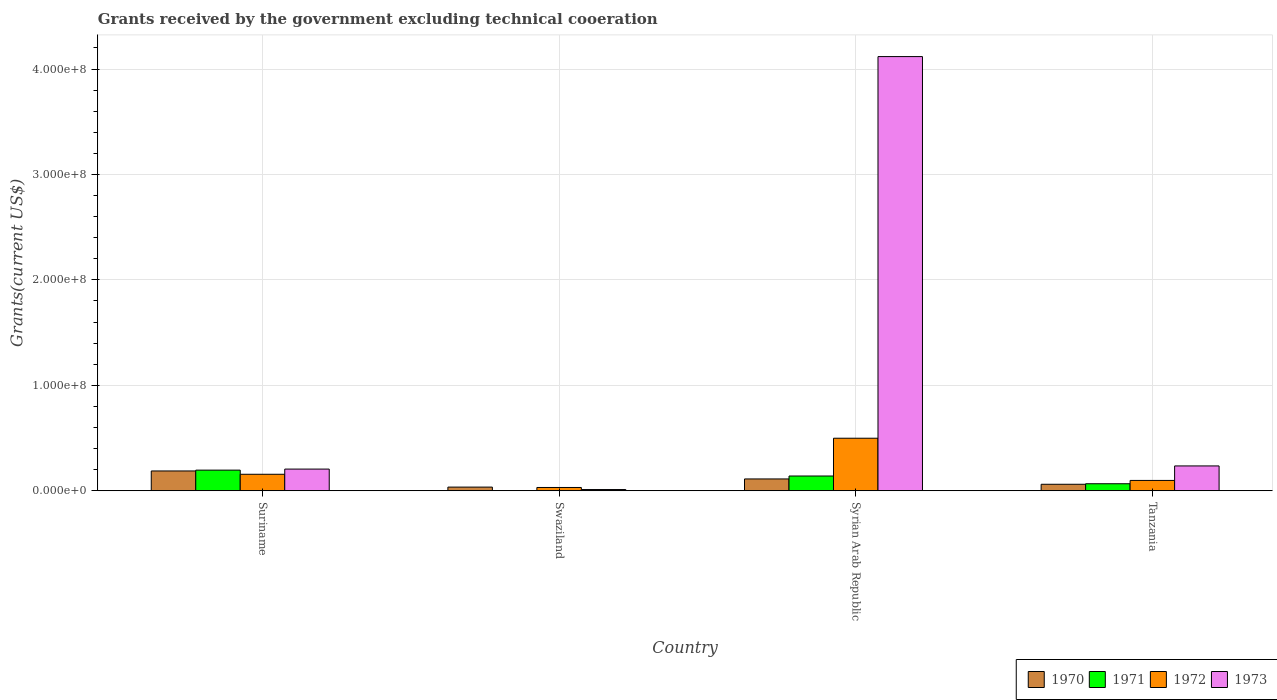How many different coloured bars are there?
Make the answer very short. 4. How many groups of bars are there?
Your response must be concise. 4. Are the number of bars on each tick of the X-axis equal?
Keep it short and to the point. No. How many bars are there on the 3rd tick from the left?
Give a very brief answer. 4. How many bars are there on the 2nd tick from the right?
Make the answer very short. 4. What is the label of the 3rd group of bars from the left?
Keep it short and to the point. Syrian Arab Republic. In how many cases, is the number of bars for a given country not equal to the number of legend labels?
Provide a short and direct response. 1. What is the total grants received by the government in 1971 in Suriname?
Your answer should be compact. 1.96e+07. Across all countries, what is the maximum total grants received by the government in 1971?
Ensure brevity in your answer.  1.96e+07. Across all countries, what is the minimum total grants received by the government in 1971?
Keep it short and to the point. 0. In which country was the total grants received by the government in 1972 maximum?
Provide a succinct answer. Syrian Arab Republic. What is the total total grants received by the government in 1970 in the graph?
Keep it short and to the point. 3.97e+07. What is the difference between the total grants received by the government in 1972 in Swaziland and that in Syrian Arab Republic?
Provide a short and direct response. -4.67e+07. What is the difference between the total grants received by the government in 1972 in Swaziland and the total grants received by the government in 1971 in Tanzania?
Provide a short and direct response. -3.54e+06. What is the average total grants received by the government in 1972 per country?
Offer a terse response. 1.96e+07. What is the difference between the total grants received by the government of/in 1971 and total grants received by the government of/in 1970 in Syrian Arab Republic?
Your response must be concise. 2.78e+06. What is the ratio of the total grants received by the government in 1973 in Suriname to that in Syrian Arab Republic?
Your answer should be compact. 0.05. Is the total grants received by the government in 1970 in Suriname less than that in Syrian Arab Republic?
Your answer should be very brief. No. What is the difference between the highest and the second highest total grants received by the government in 1971?
Give a very brief answer. 5.58e+06. What is the difference between the highest and the lowest total grants received by the government in 1973?
Keep it short and to the point. 4.11e+08. In how many countries, is the total grants received by the government in 1973 greater than the average total grants received by the government in 1973 taken over all countries?
Your response must be concise. 1. Is it the case that in every country, the sum of the total grants received by the government in 1971 and total grants received by the government in 1972 is greater than the sum of total grants received by the government in 1970 and total grants received by the government in 1973?
Keep it short and to the point. No. Is it the case that in every country, the sum of the total grants received by the government in 1970 and total grants received by the government in 1971 is greater than the total grants received by the government in 1972?
Your response must be concise. No. How many bars are there?
Keep it short and to the point. 15. How many countries are there in the graph?
Keep it short and to the point. 4. Does the graph contain grids?
Your answer should be compact. Yes. Where does the legend appear in the graph?
Your response must be concise. Bottom right. How many legend labels are there?
Provide a succinct answer. 4. What is the title of the graph?
Ensure brevity in your answer.  Grants received by the government excluding technical cooeration. What is the label or title of the X-axis?
Offer a very short reply. Country. What is the label or title of the Y-axis?
Keep it short and to the point. Grants(current US$). What is the Grants(current US$) in 1970 in Suriname?
Your answer should be compact. 1.88e+07. What is the Grants(current US$) in 1971 in Suriname?
Keep it short and to the point. 1.96e+07. What is the Grants(current US$) in 1972 in Suriname?
Give a very brief answer. 1.57e+07. What is the Grants(current US$) of 1973 in Suriname?
Keep it short and to the point. 2.06e+07. What is the Grants(current US$) of 1970 in Swaziland?
Your answer should be compact. 3.49e+06. What is the Grants(current US$) in 1971 in Swaziland?
Provide a succinct answer. 0. What is the Grants(current US$) in 1972 in Swaziland?
Your response must be concise. 3.14e+06. What is the Grants(current US$) of 1973 in Swaziland?
Offer a very short reply. 1.18e+06. What is the Grants(current US$) of 1970 in Syrian Arab Republic?
Provide a succinct answer. 1.12e+07. What is the Grants(current US$) in 1971 in Syrian Arab Republic?
Offer a terse response. 1.40e+07. What is the Grants(current US$) of 1972 in Syrian Arab Republic?
Your answer should be very brief. 4.98e+07. What is the Grants(current US$) in 1973 in Syrian Arab Republic?
Give a very brief answer. 4.12e+08. What is the Grants(current US$) in 1970 in Tanzania?
Offer a very short reply. 6.17e+06. What is the Grants(current US$) in 1971 in Tanzania?
Provide a succinct answer. 6.68e+06. What is the Grants(current US$) of 1972 in Tanzania?
Offer a very short reply. 9.82e+06. What is the Grants(current US$) of 1973 in Tanzania?
Ensure brevity in your answer.  2.36e+07. Across all countries, what is the maximum Grants(current US$) in 1970?
Provide a short and direct response. 1.88e+07. Across all countries, what is the maximum Grants(current US$) of 1971?
Make the answer very short. 1.96e+07. Across all countries, what is the maximum Grants(current US$) of 1972?
Make the answer very short. 4.98e+07. Across all countries, what is the maximum Grants(current US$) of 1973?
Offer a terse response. 4.12e+08. Across all countries, what is the minimum Grants(current US$) in 1970?
Your response must be concise. 3.49e+06. Across all countries, what is the minimum Grants(current US$) of 1972?
Your answer should be compact. 3.14e+06. Across all countries, what is the minimum Grants(current US$) of 1973?
Provide a succinct answer. 1.18e+06. What is the total Grants(current US$) of 1970 in the graph?
Provide a short and direct response. 3.97e+07. What is the total Grants(current US$) in 1971 in the graph?
Your response must be concise. 4.03e+07. What is the total Grants(current US$) in 1972 in the graph?
Keep it short and to the point. 7.85e+07. What is the total Grants(current US$) in 1973 in the graph?
Provide a short and direct response. 4.57e+08. What is the difference between the Grants(current US$) of 1970 in Suriname and that in Swaziland?
Provide a succinct answer. 1.53e+07. What is the difference between the Grants(current US$) in 1972 in Suriname and that in Swaziland?
Your answer should be compact. 1.25e+07. What is the difference between the Grants(current US$) in 1973 in Suriname and that in Swaziland?
Provide a short and direct response. 1.94e+07. What is the difference between the Grants(current US$) of 1970 in Suriname and that in Syrian Arab Republic?
Keep it short and to the point. 7.58e+06. What is the difference between the Grants(current US$) of 1971 in Suriname and that in Syrian Arab Republic?
Give a very brief answer. 5.58e+06. What is the difference between the Grants(current US$) of 1972 in Suriname and that in Syrian Arab Republic?
Your answer should be compact. -3.42e+07. What is the difference between the Grants(current US$) in 1973 in Suriname and that in Syrian Arab Republic?
Your answer should be compact. -3.91e+08. What is the difference between the Grants(current US$) in 1970 in Suriname and that in Tanzania?
Provide a short and direct response. 1.26e+07. What is the difference between the Grants(current US$) of 1971 in Suriname and that in Tanzania?
Offer a very short reply. 1.29e+07. What is the difference between the Grants(current US$) in 1972 in Suriname and that in Tanzania?
Offer a very short reply. 5.84e+06. What is the difference between the Grants(current US$) of 1970 in Swaziland and that in Syrian Arab Republic?
Provide a succinct answer. -7.74e+06. What is the difference between the Grants(current US$) in 1972 in Swaziland and that in Syrian Arab Republic?
Give a very brief answer. -4.67e+07. What is the difference between the Grants(current US$) in 1973 in Swaziland and that in Syrian Arab Republic?
Your response must be concise. -4.11e+08. What is the difference between the Grants(current US$) of 1970 in Swaziland and that in Tanzania?
Give a very brief answer. -2.68e+06. What is the difference between the Grants(current US$) in 1972 in Swaziland and that in Tanzania?
Your answer should be very brief. -6.68e+06. What is the difference between the Grants(current US$) of 1973 in Swaziland and that in Tanzania?
Make the answer very short. -2.24e+07. What is the difference between the Grants(current US$) of 1970 in Syrian Arab Republic and that in Tanzania?
Offer a very short reply. 5.06e+06. What is the difference between the Grants(current US$) in 1971 in Syrian Arab Republic and that in Tanzania?
Provide a short and direct response. 7.33e+06. What is the difference between the Grants(current US$) in 1972 in Syrian Arab Republic and that in Tanzania?
Ensure brevity in your answer.  4.00e+07. What is the difference between the Grants(current US$) of 1973 in Syrian Arab Republic and that in Tanzania?
Give a very brief answer. 3.88e+08. What is the difference between the Grants(current US$) in 1970 in Suriname and the Grants(current US$) in 1972 in Swaziland?
Provide a short and direct response. 1.57e+07. What is the difference between the Grants(current US$) of 1970 in Suriname and the Grants(current US$) of 1973 in Swaziland?
Provide a succinct answer. 1.76e+07. What is the difference between the Grants(current US$) of 1971 in Suriname and the Grants(current US$) of 1972 in Swaziland?
Ensure brevity in your answer.  1.64e+07. What is the difference between the Grants(current US$) in 1971 in Suriname and the Grants(current US$) in 1973 in Swaziland?
Keep it short and to the point. 1.84e+07. What is the difference between the Grants(current US$) in 1972 in Suriname and the Grants(current US$) in 1973 in Swaziland?
Make the answer very short. 1.45e+07. What is the difference between the Grants(current US$) of 1970 in Suriname and the Grants(current US$) of 1971 in Syrian Arab Republic?
Provide a short and direct response. 4.80e+06. What is the difference between the Grants(current US$) in 1970 in Suriname and the Grants(current US$) in 1972 in Syrian Arab Republic?
Give a very brief answer. -3.10e+07. What is the difference between the Grants(current US$) of 1970 in Suriname and the Grants(current US$) of 1973 in Syrian Arab Republic?
Provide a succinct answer. -3.93e+08. What is the difference between the Grants(current US$) in 1971 in Suriname and the Grants(current US$) in 1972 in Syrian Arab Republic?
Ensure brevity in your answer.  -3.03e+07. What is the difference between the Grants(current US$) in 1971 in Suriname and the Grants(current US$) in 1973 in Syrian Arab Republic?
Offer a terse response. -3.92e+08. What is the difference between the Grants(current US$) of 1972 in Suriname and the Grants(current US$) of 1973 in Syrian Arab Republic?
Keep it short and to the point. -3.96e+08. What is the difference between the Grants(current US$) in 1970 in Suriname and the Grants(current US$) in 1971 in Tanzania?
Your answer should be very brief. 1.21e+07. What is the difference between the Grants(current US$) of 1970 in Suriname and the Grants(current US$) of 1972 in Tanzania?
Your response must be concise. 8.99e+06. What is the difference between the Grants(current US$) in 1970 in Suriname and the Grants(current US$) in 1973 in Tanzania?
Your answer should be compact. -4.77e+06. What is the difference between the Grants(current US$) in 1971 in Suriname and the Grants(current US$) in 1972 in Tanzania?
Provide a short and direct response. 9.77e+06. What is the difference between the Grants(current US$) of 1971 in Suriname and the Grants(current US$) of 1973 in Tanzania?
Make the answer very short. -3.99e+06. What is the difference between the Grants(current US$) of 1972 in Suriname and the Grants(current US$) of 1973 in Tanzania?
Keep it short and to the point. -7.92e+06. What is the difference between the Grants(current US$) in 1970 in Swaziland and the Grants(current US$) in 1971 in Syrian Arab Republic?
Your answer should be very brief. -1.05e+07. What is the difference between the Grants(current US$) of 1970 in Swaziland and the Grants(current US$) of 1972 in Syrian Arab Republic?
Make the answer very short. -4.64e+07. What is the difference between the Grants(current US$) in 1970 in Swaziland and the Grants(current US$) in 1973 in Syrian Arab Republic?
Your answer should be compact. -4.08e+08. What is the difference between the Grants(current US$) of 1972 in Swaziland and the Grants(current US$) of 1973 in Syrian Arab Republic?
Offer a very short reply. -4.09e+08. What is the difference between the Grants(current US$) of 1970 in Swaziland and the Grants(current US$) of 1971 in Tanzania?
Your answer should be very brief. -3.19e+06. What is the difference between the Grants(current US$) of 1970 in Swaziland and the Grants(current US$) of 1972 in Tanzania?
Your response must be concise. -6.33e+06. What is the difference between the Grants(current US$) in 1970 in Swaziland and the Grants(current US$) in 1973 in Tanzania?
Your answer should be very brief. -2.01e+07. What is the difference between the Grants(current US$) in 1972 in Swaziland and the Grants(current US$) in 1973 in Tanzania?
Your answer should be very brief. -2.04e+07. What is the difference between the Grants(current US$) of 1970 in Syrian Arab Republic and the Grants(current US$) of 1971 in Tanzania?
Offer a terse response. 4.55e+06. What is the difference between the Grants(current US$) of 1970 in Syrian Arab Republic and the Grants(current US$) of 1972 in Tanzania?
Provide a succinct answer. 1.41e+06. What is the difference between the Grants(current US$) of 1970 in Syrian Arab Republic and the Grants(current US$) of 1973 in Tanzania?
Your answer should be very brief. -1.24e+07. What is the difference between the Grants(current US$) in 1971 in Syrian Arab Republic and the Grants(current US$) in 1972 in Tanzania?
Offer a very short reply. 4.19e+06. What is the difference between the Grants(current US$) of 1971 in Syrian Arab Republic and the Grants(current US$) of 1973 in Tanzania?
Your answer should be compact. -9.57e+06. What is the difference between the Grants(current US$) of 1972 in Syrian Arab Republic and the Grants(current US$) of 1973 in Tanzania?
Ensure brevity in your answer.  2.63e+07. What is the average Grants(current US$) in 1970 per country?
Offer a very short reply. 9.92e+06. What is the average Grants(current US$) in 1971 per country?
Keep it short and to the point. 1.01e+07. What is the average Grants(current US$) of 1972 per country?
Keep it short and to the point. 1.96e+07. What is the average Grants(current US$) in 1973 per country?
Provide a succinct answer. 1.14e+08. What is the difference between the Grants(current US$) in 1970 and Grants(current US$) in 1971 in Suriname?
Provide a succinct answer. -7.80e+05. What is the difference between the Grants(current US$) in 1970 and Grants(current US$) in 1972 in Suriname?
Give a very brief answer. 3.15e+06. What is the difference between the Grants(current US$) in 1970 and Grants(current US$) in 1973 in Suriname?
Give a very brief answer. -1.77e+06. What is the difference between the Grants(current US$) of 1971 and Grants(current US$) of 1972 in Suriname?
Your response must be concise. 3.93e+06. What is the difference between the Grants(current US$) in 1971 and Grants(current US$) in 1973 in Suriname?
Make the answer very short. -9.90e+05. What is the difference between the Grants(current US$) of 1972 and Grants(current US$) of 1973 in Suriname?
Make the answer very short. -4.92e+06. What is the difference between the Grants(current US$) in 1970 and Grants(current US$) in 1973 in Swaziland?
Offer a very short reply. 2.31e+06. What is the difference between the Grants(current US$) in 1972 and Grants(current US$) in 1973 in Swaziland?
Give a very brief answer. 1.96e+06. What is the difference between the Grants(current US$) in 1970 and Grants(current US$) in 1971 in Syrian Arab Republic?
Provide a short and direct response. -2.78e+06. What is the difference between the Grants(current US$) of 1970 and Grants(current US$) of 1972 in Syrian Arab Republic?
Provide a succinct answer. -3.86e+07. What is the difference between the Grants(current US$) of 1970 and Grants(current US$) of 1973 in Syrian Arab Republic?
Provide a succinct answer. -4.01e+08. What is the difference between the Grants(current US$) of 1971 and Grants(current US$) of 1972 in Syrian Arab Republic?
Provide a short and direct response. -3.58e+07. What is the difference between the Grants(current US$) in 1971 and Grants(current US$) in 1973 in Syrian Arab Republic?
Make the answer very short. -3.98e+08. What is the difference between the Grants(current US$) in 1972 and Grants(current US$) in 1973 in Syrian Arab Republic?
Your answer should be compact. -3.62e+08. What is the difference between the Grants(current US$) in 1970 and Grants(current US$) in 1971 in Tanzania?
Keep it short and to the point. -5.10e+05. What is the difference between the Grants(current US$) of 1970 and Grants(current US$) of 1972 in Tanzania?
Make the answer very short. -3.65e+06. What is the difference between the Grants(current US$) of 1970 and Grants(current US$) of 1973 in Tanzania?
Provide a succinct answer. -1.74e+07. What is the difference between the Grants(current US$) of 1971 and Grants(current US$) of 1972 in Tanzania?
Offer a terse response. -3.14e+06. What is the difference between the Grants(current US$) of 1971 and Grants(current US$) of 1973 in Tanzania?
Provide a short and direct response. -1.69e+07. What is the difference between the Grants(current US$) in 1972 and Grants(current US$) in 1973 in Tanzania?
Provide a short and direct response. -1.38e+07. What is the ratio of the Grants(current US$) of 1970 in Suriname to that in Swaziland?
Your response must be concise. 5.39. What is the ratio of the Grants(current US$) of 1972 in Suriname to that in Swaziland?
Your response must be concise. 4.99. What is the ratio of the Grants(current US$) of 1973 in Suriname to that in Swaziland?
Provide a succinct answer. 17.44. What is the ratio of the Grants(current US$) of 1970 in Suriname to that in Syrian Arab Republic?
Offer a very short reply. 1.68. What is the ratio of the Grants(current US$) of 1971 in Suriname to that in Syrian Arab Republic?
Keep it short and to the point. 1.4. What is the ratio of the Grants(current US$) of 1972 in Suriname to that in Syrian Arab Republic?
Offer a very short reply. 0.31. What is the ratio of the Grants(current US$) in 1970 in Suriname to that in Tanzania?
Provide a short and direct response. 3.05. What is the ratio of the Grants(current US$) of 1971 in Suriname to that in Tanzania?
Offer a terse response. 2.93. What is the ratio of the Grants(current US$) in 1972 in Suriname to that in Tanzania?
Give a very brief answer. 1.59. What is the ratio of the Grants(current US$) in 1973 in Suriname to that in Tanzania?
Ensure brevity in your answer.  0.87. What is the ratio of the Grants(current US$) in 1970 in Swaziland to that in Syrian Arab Republic?
Give a very brief answer. 0.31. What is the ratio of the Grants(current US$) in 1972 in Swaziland to that in Syrian Arab Republic?
Make the answer very short. 0.06. What is the ratio of the Grants(current US$) of 1973 in Swaziland to that in Syrian Arab Republic?
Offer a terse response. 0. What is the ratio of the Grants(current US$) of 1970 in Swaziland to that in Tanzania?
Offer a very short reply. 0.57. What is the ratio of the Grants(current US$) of 1972 in Swaziland to that in Tanzania?
Your answer should be compact. 0.32. What is the ratio of the Grants(current US$) of 1973 in Swaziland to that in Tanzania?
Offer a very short reply. 0.05. What is the ratio of the Grants(current US$) in 1970 in Syrian Arab Republic to that in Tanzania?
Make the answer very short. 1.82. What is the ratio of the Grants(current US$) in 1971 in Syrian Arab Republic to that in Tanzania?
Give a very brief answer. 2.1. What is the ratio of the Grants(current US$) in 1972 in Syrian Arab Republic to that in Tanzania?
Give a very brief answer. 5.08. What is the ratio of the Grants(current US$) in 1973 in Syrian Arab Republic to that in Tanzania?
Ensure brevity in your answer.  17.46. What is the difference between the highest and the second highest Grants(current US$) in 1970?
Ensure brevity in your answer.  7.58e+06. What is the difference between the highest and the second highest Grants(current US$) of 1971?
Make the answer very short. 5.58e+06. What is the difference between the highest and the second highest Grants(current US$) in 1972?
Offer a very short reply. 3.42e+07. What is the difference between the highest and the second highest Grants(current US$) of 1973?
Your answer should be very brief. 3.88e+08. What is the difference between the highest and the lowest Grants(current US$) in 1970?
Provide a succinct answer. 1.53e+07. What is the difference between the highest and the lowest Grants(current US$) in 1971?
Your answer should be compact. 1.96e+07. What is the difference between the highest and the lowest Grants(current US$) in 1972?
Offer a terse response. 4.67e+07. What is the difference between the highest and the lowest Grants(current US$) in 1973?
Ensure brevity in your answer.  4.11e+08. 